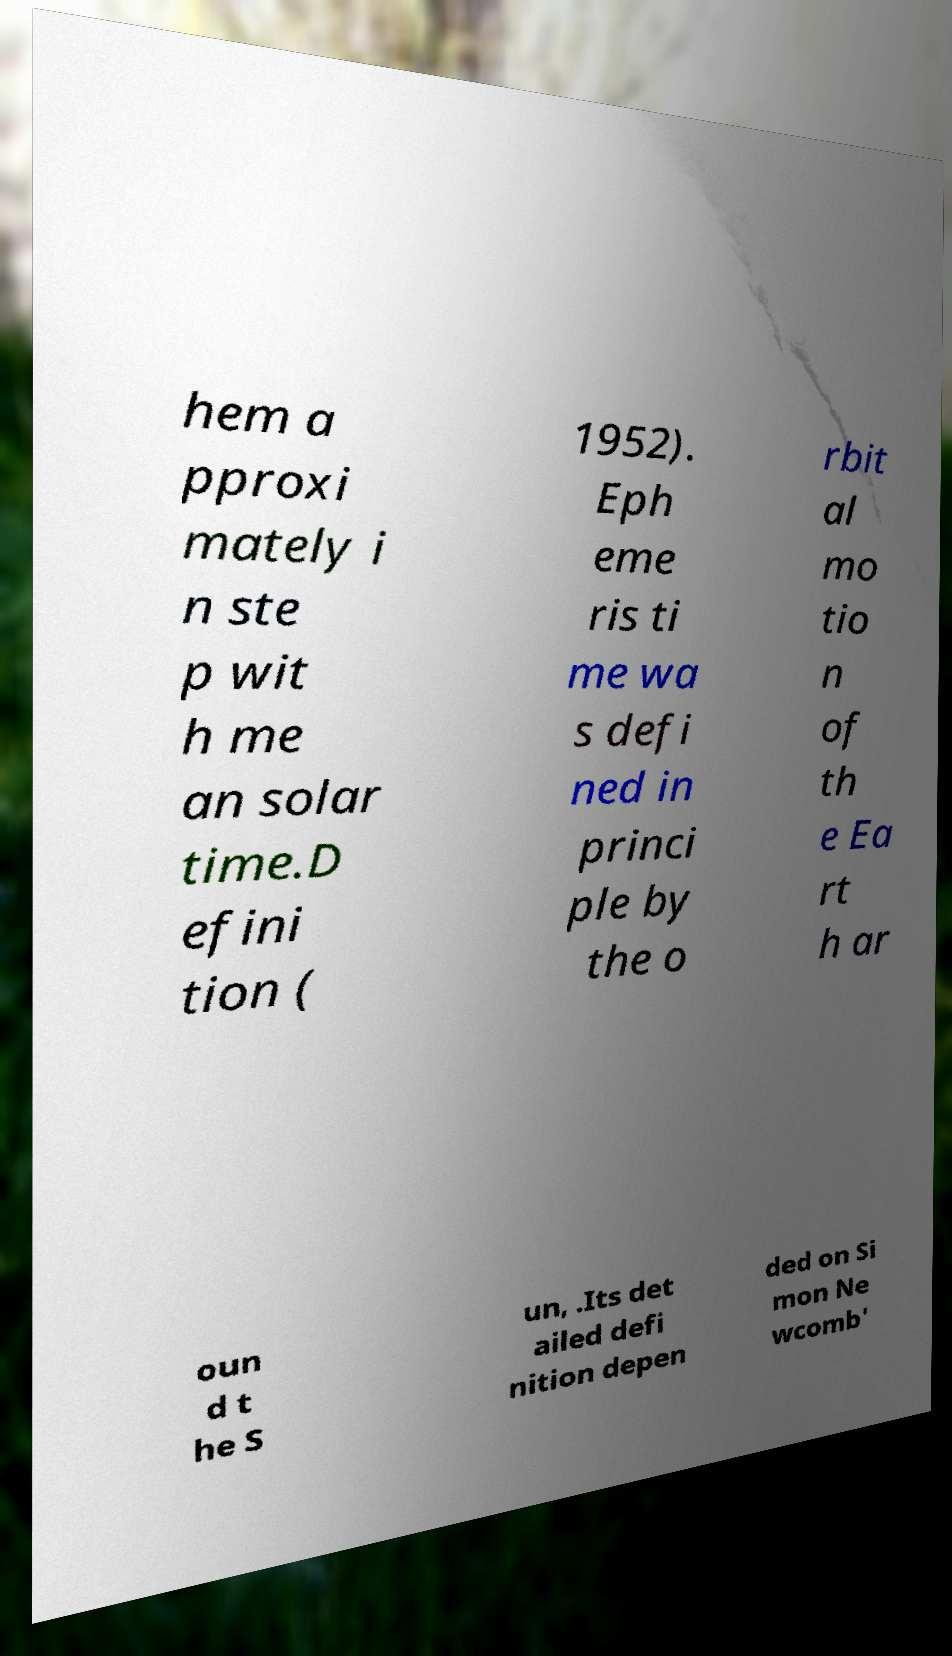For documentation purposes, I need the text within this image transcribed. Could you provide that? hem a pproxi mately i n ste p wit h me an solar time.D efini tion ( 1952). Eph eme ris ti me wa s defi ned in princi ple by the o rbit al mo tio n of th e Ea rt h ar oun d t he S un, .Its det ailed defi nition depen ded on Si mon Ne wcomb' 